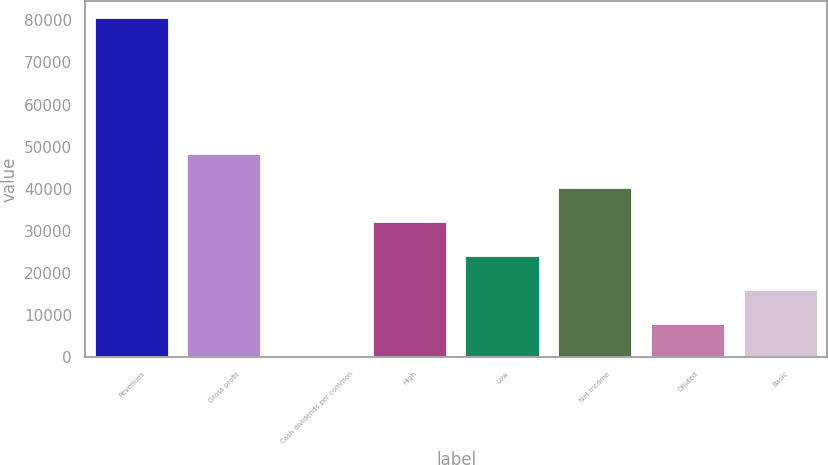Convert chart to OTSL. <chart><loc_0><loc_0><loc_500><loc_500><bar_chart><fcel>Revenues<fcel>Gross profit<fcel>Cash dividends per common<fcel>High<fcel>Low<fcel>Net income<fcel>Diluted<fcel>Basic<nl><fcel>80514.6<fcel>48308.9<fcel>0.24<fcel>32206<fcel>24154.6<fcel>40257.4<fcel>8051.68<fcel>16103.1<nl></chart> 